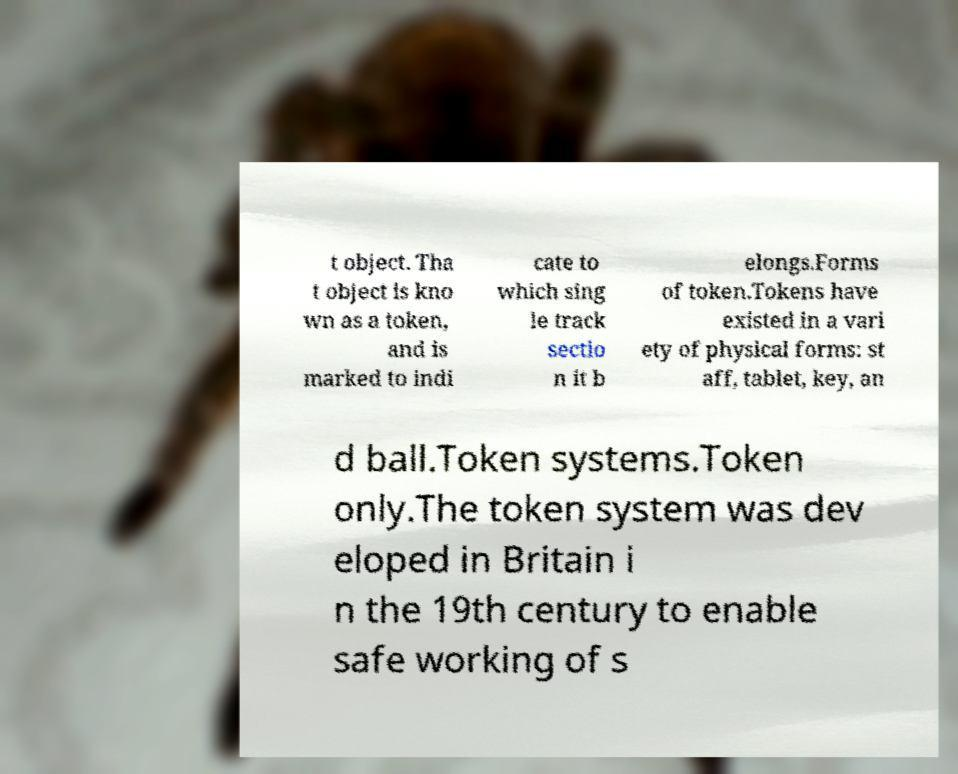Please read and relay the text visible in this image. What does it say? t object. Tha t object is kno wn as a token, and is marked to indi cate to which sing le track sectio n it b elongs.Forms of token.Tokens have existed in a vari ety of physical forms: st aff, tablet, key, an d ball.Token systems.Token only.The token system was dev eloped in Britain i n the 19th century to enable safe working of s 